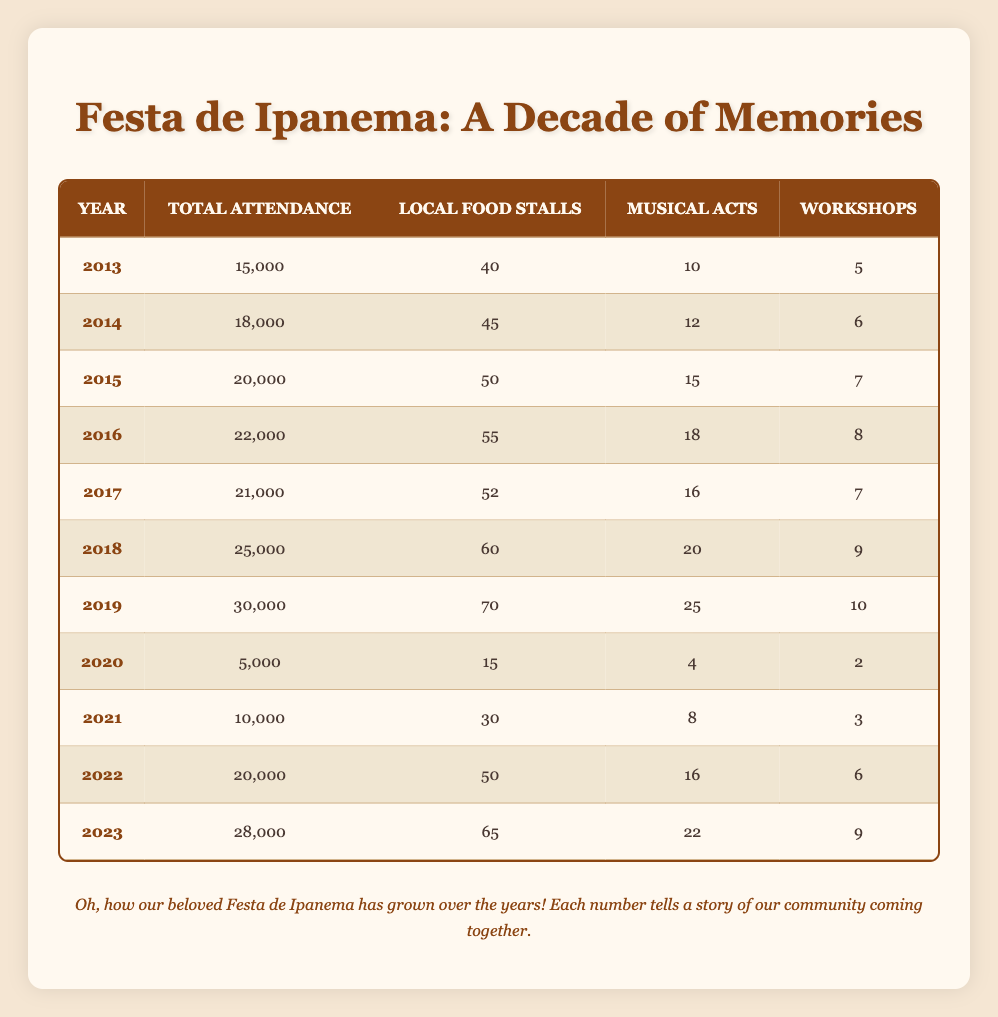What year had the highest total attendance at the Festa de Ipanema? Looking at the "Total Attendance" column, the highest number is 30000, which corresponds to the year 2019.
Answer: 2019 How many local food stalls were there in 2018? Referring to the "Local Food Stalls" column, in 2018 there were 60 stalls.
Answer: 60 What is the average total attendance for the years 2013 to 2019? The total attendance for the years 2013 to 2019 is 15,000 + 18,000 + 20,000 + 22,000 + 21,000 + 25,000 + 30,000, which equals  141,000. There are 7 years, so the average is 141,000 / 7 = 20,142.86, which rounds to 20,143.
Answer: 20,143 Did the number of musical acts increase every year? By comparing each year's "Musical Acts" column, we see the counts: 10 (2013), 12 (2014), 15 (2015), 18 (2016), 16 (2017), 20 (2018), 25 (2019), 4 (2020), 8 (2021), 16 (2022), 22 (2023). There was a decrease from 2019 to 2020. Thus, the answer is no.
Answer: No How many more workshops were held in 2023 compared to 2018? In 2023, there were 9 workshops, and in 2018 there were 9 as well. So the difference is 9 - 9 = 0.
Answer: 0 What was the total attendance decrease from 2019 to 2020? The attendance in 2019 was 30000 and in 2020 it was 5000, so the decrease is 30000 - 5000 = 25000.
Answer: 25000 In which year did the festival experience the largest increase in total attendance compared to the previous year? Comparing the total attendance year-over-year, the largest increase is from 2021 to 2022, a difference of 10,000 (20,000 - 10,000).
Answer: 2022 Was there an overall increase in local food stalls from 2013 to 2023? In 2013 there were 40 stalls and in 2023 there were 65 stalls. This shows an increase, so the answer is yes.
Answer: Yes What was the median total attendance for the years 2013 to 2023? The total attendance for each year is sorted in ascending order: 5000, 10000, 15000, 18000, 20000, 20000, 21000, 22000, 25000, 28000, 30000. The median is the average of the 5th and 6th values in this ordered list, which are 20000 and 21000. Thus, the median is (20000 + 21000) / 2 = 20500.
Answer: 20500 